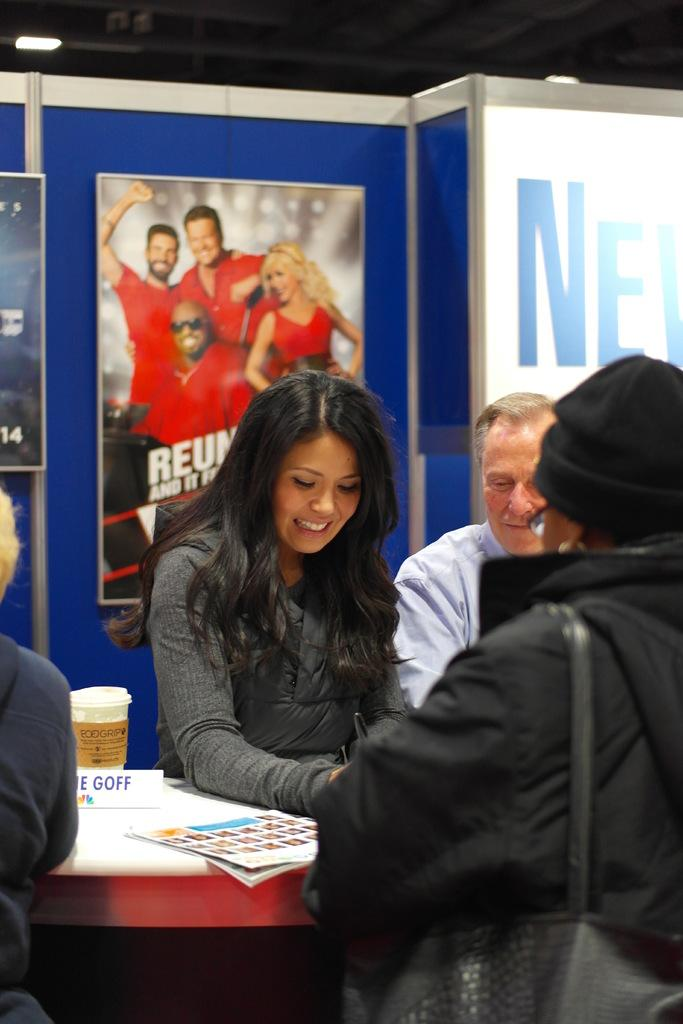What is located in the middle of the image? There are persons in the middle of the image. What object can be seen on the table in the image? There is a cup on the table in the image. What is present in the background of the image? There is a hoarding in the background of the image. Can you describe the lighting in the image? There is light in the image. What type of soup is being served in the image? There is no soup present in the image. What is the ground made of in the image? The ground is not visible in the image, as it focuses on the persons, table, cup, and hoarding. 